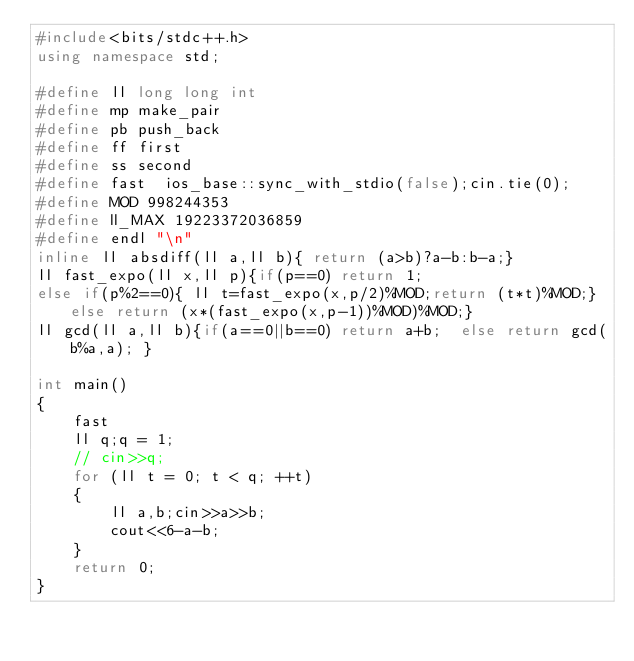Convert code to text. <code><loc_0><loc_0><loc_500><loc_500><_C++_>#include<bits/stdc++.h> 
using namespace std;
 
#define ll long long int
#define mp make_pair 
#define pb push_back
#define ff first
#define ss second
#define fast  ios_base::sync_with_stdio(false);cin.tie(0);
#define MOD 998244353
#define ll_MAX 19223372036859
#define endl "\n"
inline ll absdiff(ll a,ll b){ return (a>b)?a-b:b-a;}
ll fast_expo(ll x,ll p){if(p==0) return 1;
else if(p%2==0){ ll t=fast_expo(x,p/2)%MOD;return (t*t)%MOD;} else return (x*(fast_expo(x,p-1))%MOD)%MOD;}
ll gcd(ll a,ll b){if(a==0||b==0) return a+b;  else return gcd(b%a,a); }

int main()
{
    fast
    ll q;q = 1;
    // cin>>q;
    for (ll t = 0; t < q; ++t)
    {
        ll a,b;cin>>a>>b;
        cout<<6-a-b;
    }
    return 0;
}   </code> 